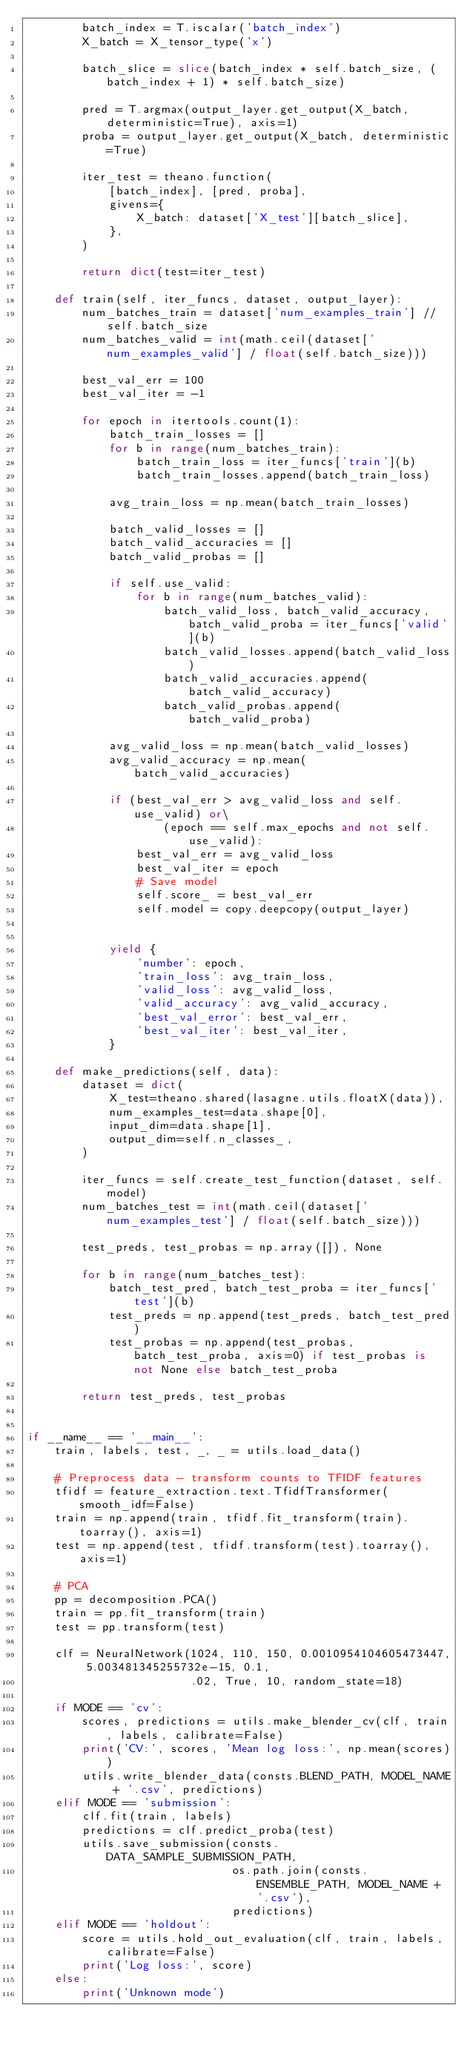Convert code to text. <code><loc_0><loc_0><loc_500><loc_500><_Python_>        batch_index = T.iscalar('batch_index')
        X_batch = X_tensor_type('x')

        batch_slice = slice(batch_index * self.batch_size, (batch_index + 1) * self.batch_size)

        pred = T.argmax(output_layer.get_output(X_batch, deterministic=True), axis=1)
        proba = output_layer.get_output(X_batch, deterministic=True)

        iter_test = theano.function(
            [batch_index], [pred, proba],
            givens={
                X_batch: dataset['X_test'][batch_slice],
            },
        )

        return dict(test=iter_test)

    def train(self, iter_funcs, dataset, output_layer):
        num_batches_train = dataset['num_examples_train'] // self.batch_size
        num_batches_valid = int(math.ceil(dataset['num_examples_valid'] / float(self.batch_size)))

        best_val_err = 100
        best_val_iter = -1

        for epoch in itertools.count(1):
            batch_train_losses = []
            for b in range(num_batches_train):
                batch_train_loss = iter_funcs['train'](b)
                batch_train_losses.append(batch_train_loss)

            avg_train_loss = np.mean(batch_train_losses)

            batch_valid_losses = []
            batch_valid_accuracies = []
            batch_valid_probas = []

            if self.use_valid:
                for b in range(num_batches_valid):
                    batch_valid_loss, batch_valid_accuracy, batch_valid_proba = iter_funcs['valid'](b)
                    batch_valid_losses.append(batch_valid_loss)
                    batch_valid_accuracies.append(batch_valid_accuracy)
                    batch_valid_probas.append(batch_valid_proba)

            avg_valid_loss = np.mean(batch_valid_losses)
            avg_valid_accuracy = np.mean(batch_valid_accuracies)

            if (best_val_err > avg_valid_loss and self.use_valid) or\
                    (epoch == self.max_epochs and not self.use_valid):
                best_val_err = avg_valid_loss
                best_val_iter = epoch
                # Save model
                self.score_ = best_val_err
                self.model = copy.deepcopy(output_layer)


            yield {
                'number': epoch,
                'train_loss': avg_train_loss,
                'valid_loss': avg_valid_loss,
                'valid_accuracy': avg_valid_accuracy,
                'best_val_error': best_val_err,
                'best_val_iter': best_val_iter,
            }

    def make_predictions(self, data):
        dataset = dict(
            X_test=theano.shared(lasagne.utils.floatX(data)),
            num_examples_test=data.shape[0],
            input_dim=data.shape[1],
            output_dim=self.n_classes_,
        )

        iter_funcs = self.create_test_function(dataset, self.model)
        num_batches_test = int(math.ceil(dataset['num_examples_test'] / float(self.batch_size)))

        test_preds, test_probas = np.array([]), None

        for b in range(num_batches_test):
            batch_test_pred, batch_test_proba = iter_funcs['test'](b)
            test_preds = np.append(test_preds, batch_test_pred)
            test_probas = np.append(test_probas, batch_test_proba, axis=0) if test_probas is not None else batch_test_proba

        return test_preds, test_probas


if __name__ == '__main__':
    train, labels, test, _, _ = utils.load_data()

    # Preprocess data - transform counts to TFIDF features
    tfidf = feature_extraction.text.TfidfTransformer(smooth_idf=False)
    train = np.append(train, tfidf.fit_transform(train).toarray(), axis=1)
    test = np.append(test, tfidf.transform(test).toarray(), axis=1)

    # PCA
    pp = decomposition.PCA()
    train = pp.fit_transform(train)
    test = pp.transform(test)

    clf = NeuralNetwork(1024, 110, 150, 0.0010954104605473447, 5.003481345255732e-15, 0.1,
                        .02, True, 10, random_state=18)

    if MODE == 'cv':
        scores, predictions = utils.make_blender_cv(clf, train, labels, calibrate=False)
        print('CV:', scores, 'Mean log loss:', np.mean(scores))
        utils.write_blender_data(consts.BLEND_PATH, MODEL_NAME + '.csv', predictions)
    elif MODE == 'submission':
        clf.fit(train, labels)
        predictions = clf.predict_proba(test)
        utils.save_submission(consts.DATA_SAMPLE_SUBMISSION_PATH,
                              os.path.join(consts.ENSEMBLE_PATH, MODEL_NAME + '.csv'),
                              predictions)
    elif MODE == 'holdout':
        score = utils.hold_out_evaluation(clf, train, labels, calibrate=False)
        print('Log loss:', score)
    else:
        print('Unknown mode')</code> 